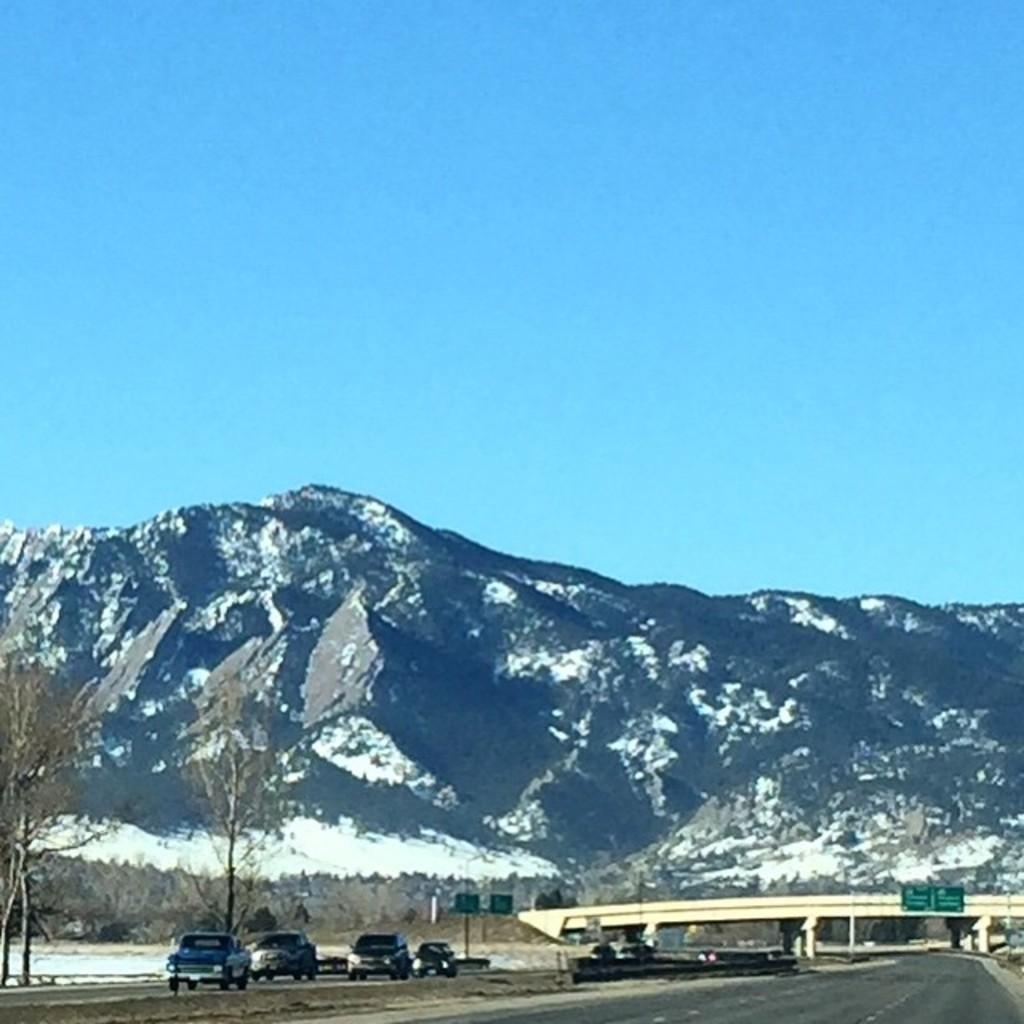What is happening on the road in the image? There are cars moving on the road in the image. What type of natural elements can be seen in the image? There are trees visible in the image. What type of signs or messages are present in the image? There are boards with text in the image. What type of structure is present in the image? There is a bridge in the image. What type of geographical feature is present in the image? There is a hill in the image. What is the color of the sky in the image? The sky is blue in the image. Is your dad celebrating his birthday on the hill in the image? There is no reference to a birthday or your dad in the image, so it is not possible to answer that question. 